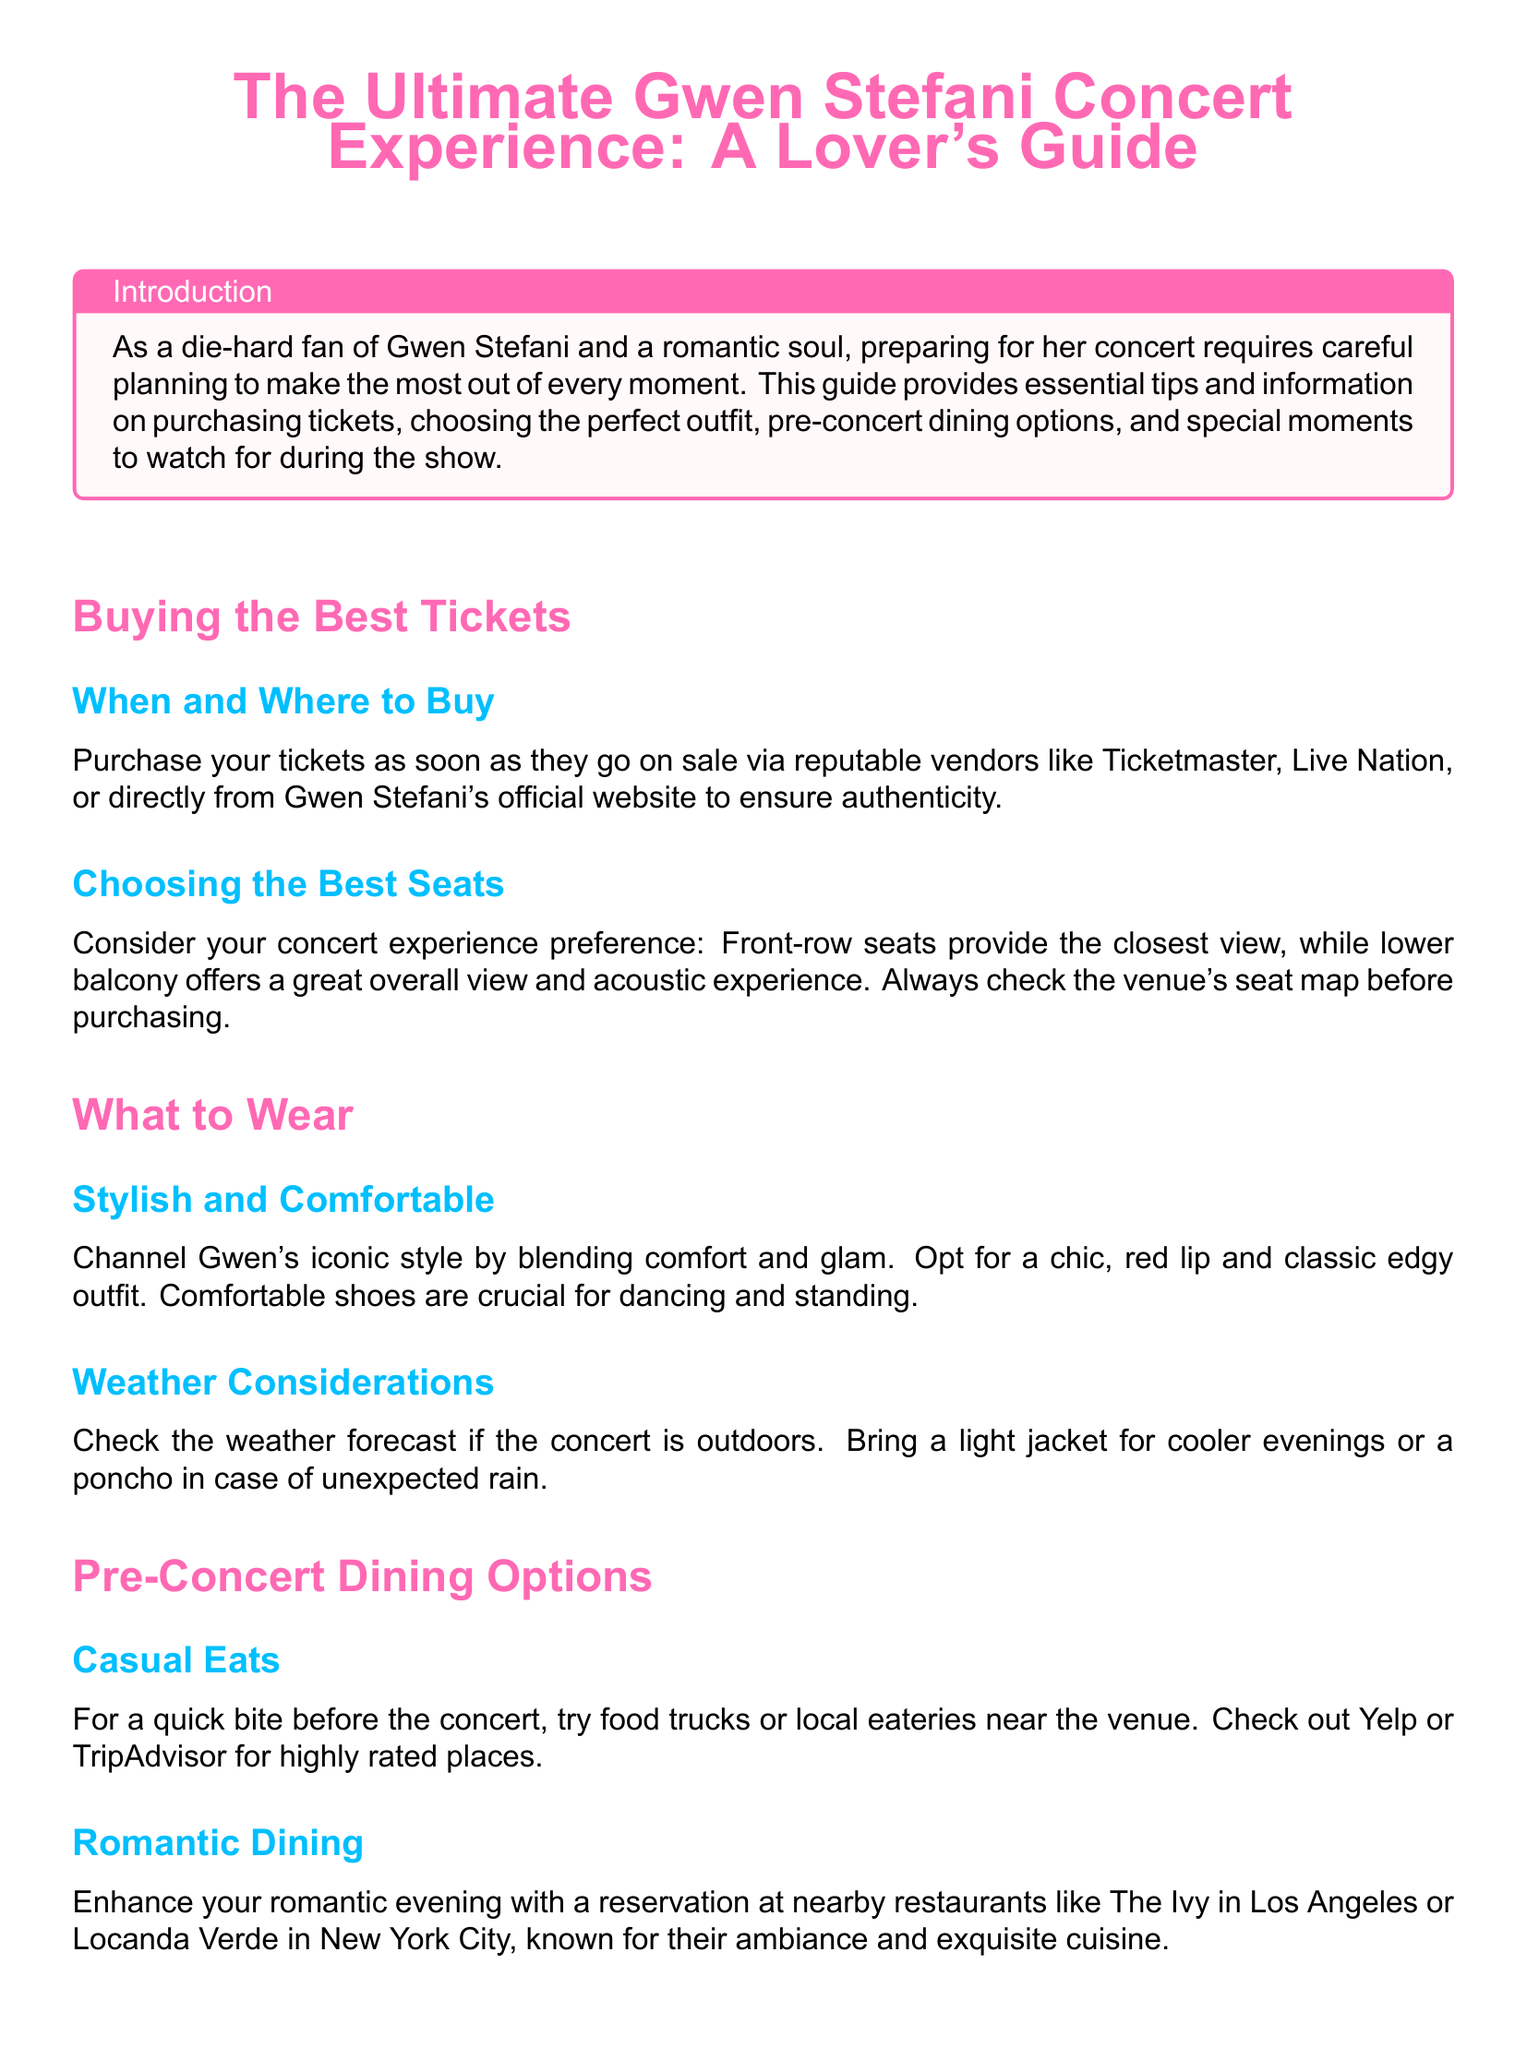what is the title of the guide? The title of the guide is prominently displayed at the beginning of the document.
Answer: The Ultimate Gwen Stefani Concert Experience: A Lover's Guide where should you purchase tickets? The document mentions reputable vendors for ticket purchases.
Answer: Ticketmaster, Live Nation, or Gwen Stefani's official website what is recommended for pre-concert dining? The guide provides suggestions for dining options before the concert.
Answer: Casual Eats or Romantic Dining what kind of shoes should you wear? The guide advises on footwear that balances comfort and style for the concert experience.
Answer: Comfortable shoes which song is mentioned as perfect for romantic moments? The document lists specific songs that create emotional and romantic ambiance during the concert.
Answer: 4 in the Morning what color is used for section headers? The document specifies a color scheme, particularly for the headers.
Answer: Gwen pink what should you check regarding the weather? The guide gives advice to prepare for different weather conditions before the concert.
Answer: Weather forecast what type of interactions should fans expect from Gwen Stefani? The document describes Gwen's engagement with her fans during the concert.
Answer: Dynamic interaction with fans 